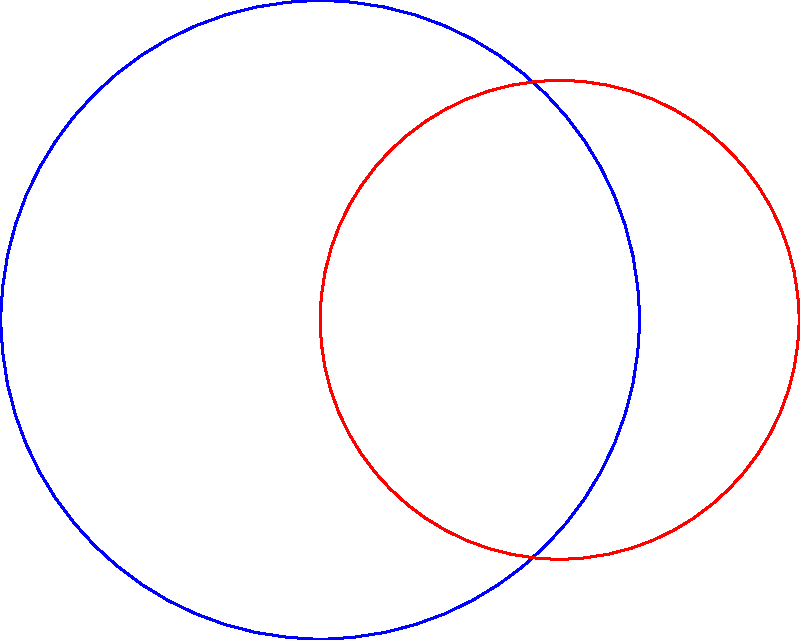In your latest avant-garde piece, you've created two overlapping paint splatters represented by intersecting circles. The blue circle, centered at O1, has a radius of 4 units, while the red circle, centered at O2, has a radius of 3 units. The distance between the centers O1 and O2 is 3 units. What is the area of the quadrilateral O1AO2B formed by connecting the centers and the intersection points of the circles? Let's approach this step-by-step:

1) First, we need to find the height of the triangle O1AO2. We can do this using the Pythagorean theorem.

2) Let the height be h. Then:
   $$(3/2)^2 + h^2 = 4^2$$
   $$9/4 + h^2 = 16$$
   $$h^2 = 16 - 9/4 = 55/4$$
   $$h = \sqrt{55/4} = \frac{\sqrt{55}}{2}$$

3) Now we can calculate the area of triangle O1AO2:
   $$Area_{O1AO2} = \frac{1}{2} * 3 * \frac{\sqrt{55}}{2} = \frac{3\sqrt{55}}{4}$$

4) The quadrilateral O1AO2B consists of two identical triangles (O1AO2 and O1BO2), so its area is twice the area of triangle O1AO2.

5) Therefore, the area of quadrilateral O1AO2B is:
   $$Area_{O1AO2B} = 2 * \frac{3\sqrt{55}}{4} = \frac{3\sqrt{55}}{2}$$
Answer: $\frac{3\sqrt{55}}{2}$ square units 